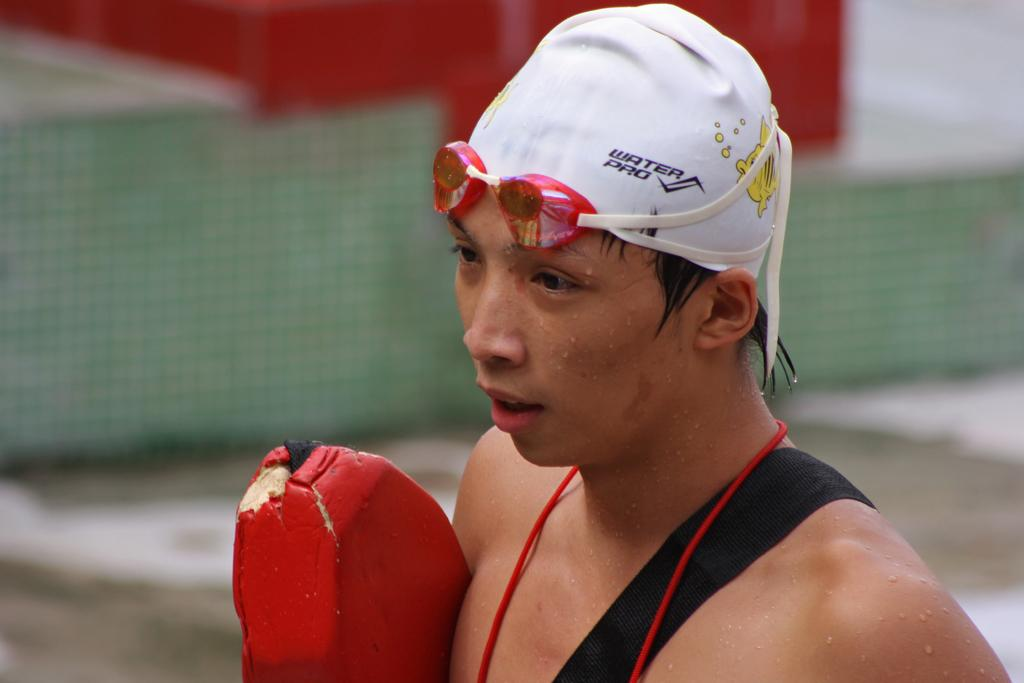What is the person in the image wearing on their head? The person in the image is wearing a white cap. How would you describe the quality of the image at the back? The image at the back is blurry. What can be seen in the background of the image? There appears to be a board and a fence in the background. What type of machine is being used by the person in the image? There is no machine visible in the image; the person is simply wearing a white cap. Can you describe the skateboarding tricks being performed by the person in the image? There is no skateboard or any indication of skateboarding in the image. 